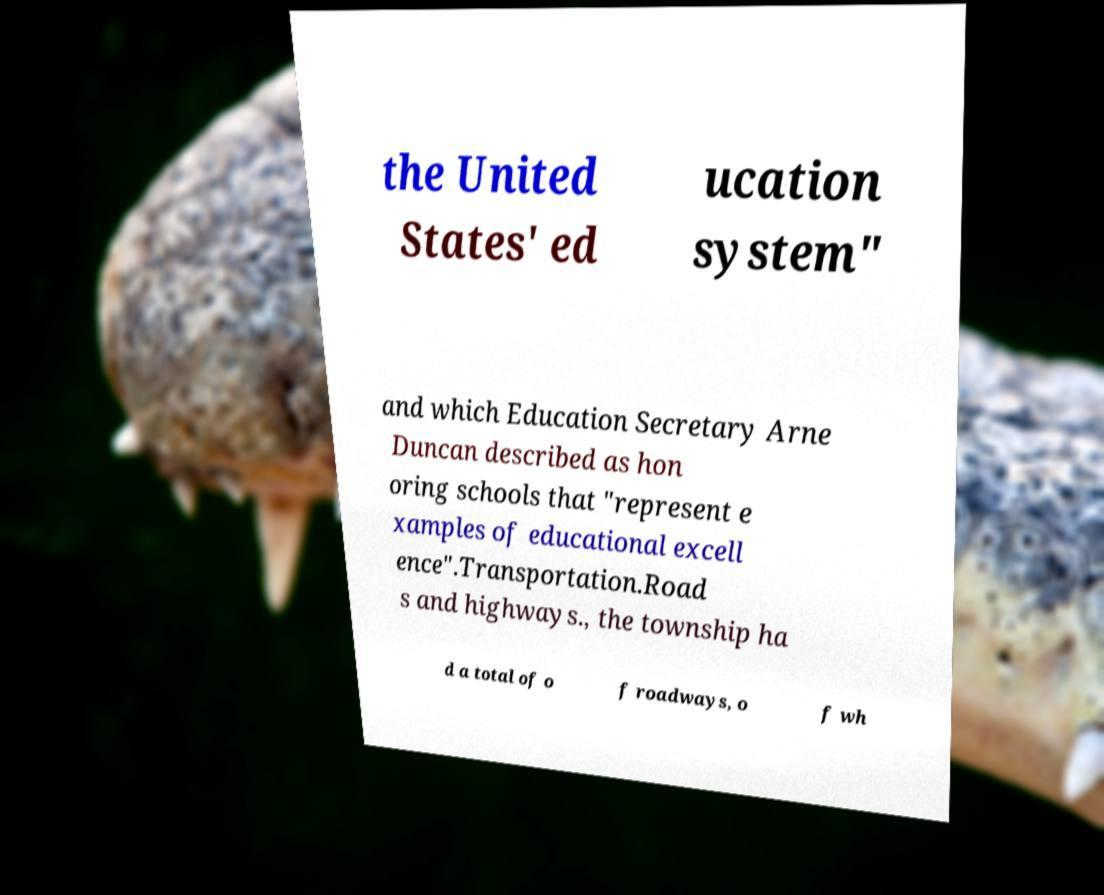Could you assist in decoding the text presented in this image and type it out clearly? the United States' ed ucation system" and which Education Secretary Arne Duncan described as hon oring schools that "represent e xamples of educational excell ence".Transportation.Road s and highways., the township ha d a total of o f roadways, o f wh 